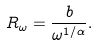Convert formula to latex. <formula><loc_0><loc_0><loc_500><loc_500>R _ { \omega } = \frac { b } { \omega ^ { 1 / \alpha } } .</formula> 